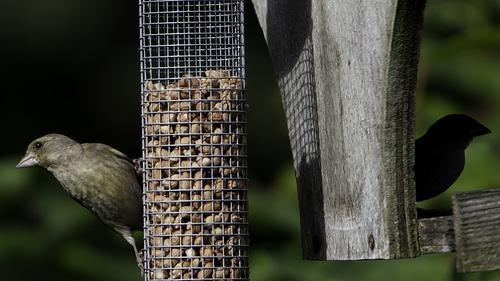Question: what is the bird doing?
Choices:
A. Flying.
B. Eating.
C. Looking away.
D. Singing.
Answer with the letter. Answer: C Question: what is behind the bird?
Choices:
A. Fountain.
B. Bird feeder.
C. Squirrel.
D. A balcony.
Answer with the letter. Answer: B Question: when was the photo taken?
Choices:
A. Night time.
B. Last year.
C. Day time.
D. Dawn.
Answer with the letter. Answer: C Question: where was the photo taken?
Choices:
A. At the birdfeeder.
B. The dance.
C. The park.
D. The picnic.
Answer with the letter. Answer: A Question: who is in the photo?
Choices:
A. A dog.
B. A girl.
C. A cat.
D. A bird.
Answer with the letter. Answer: D 